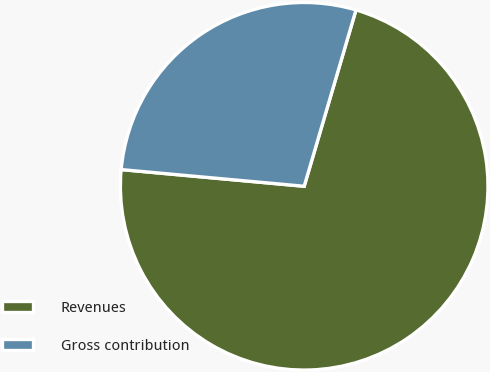Convert chart to OTSL. <chart><loc_0><loc_0><loc_500><loc_500><pie_chart><fcel>Revenues<fcel>Gross contribution<nl><fcel>71.9%<fcel>28.1%<nl></chart> 